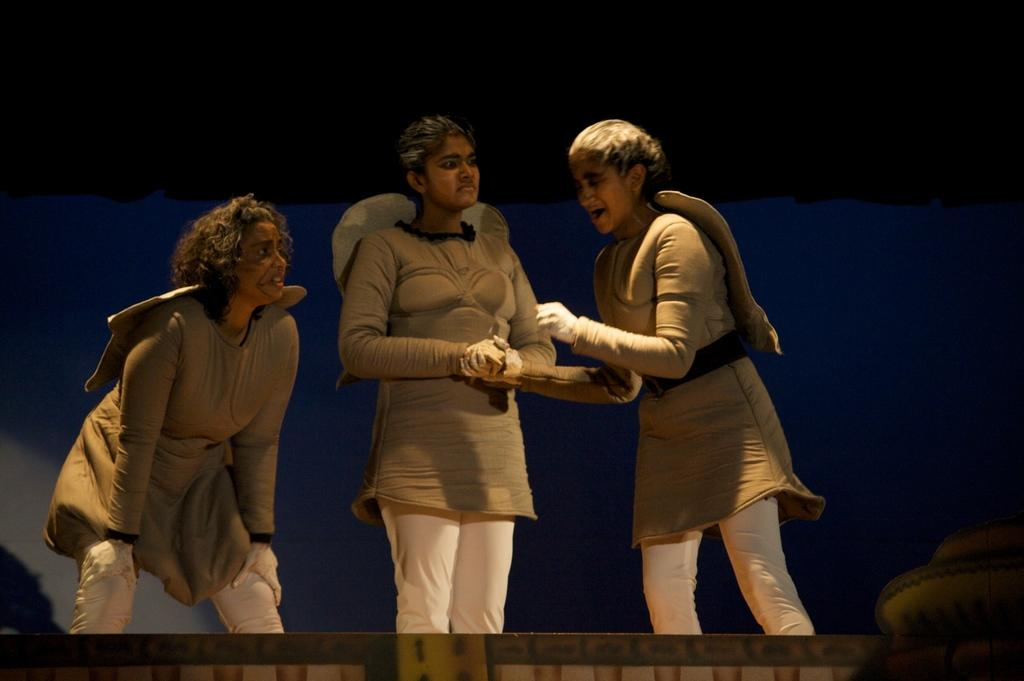How many people are in the image? There are three women in the image. What are the women doing in the image? The women are standing. What are the women wearing in the image? The women are wearing costumes. What can be seen in the background of the image? There is a wall in the background of the image. What religion do the women in the image practice? There is no information about the women's religion in the image. Can you tell me who the father of the woman in the middle is? There is no information about the women's family relationships in the image. 